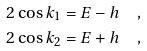<formula> <loc_0><loc_0><loc_500><loc_500>2 \cos k _ { 1 } & = E - h \quad , \\ 2 \cos k _ { 2 } & = E + h \quad ,</formula> 